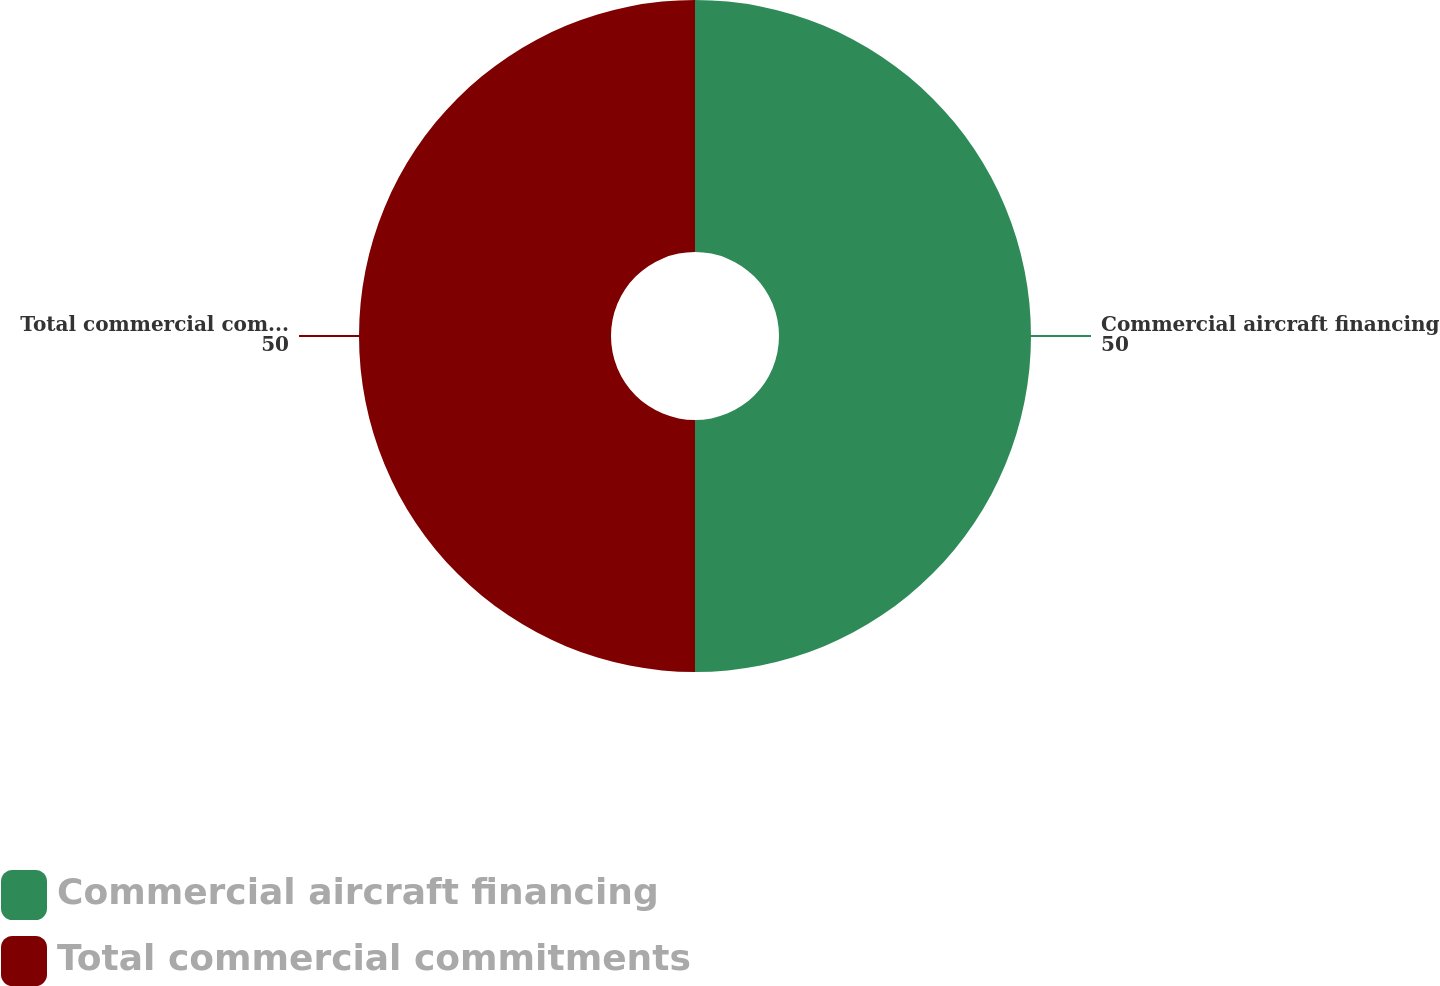<chart> <loc_0><loc_0><loc_500><loc_500><pie_chart><fcel>Commercial aircraft financing<fcel>Total commercial commitments<nl><fcel>50.0%<fcel>50.0%<nl></chart> 